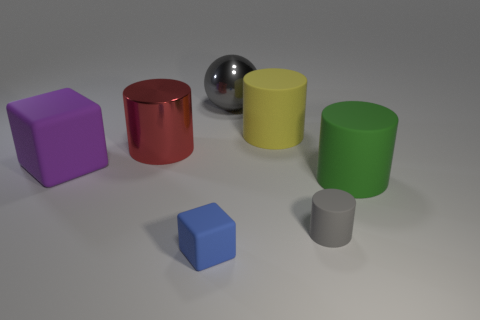How many gray metallic objects are the same size as the yellow object?
Your response must be concise. 1. There is a shiny object left of the metal sphere; is it the same size as the block that is in front of the large green rubber cylinder?
Provide a short and direct response. No. There is a gray object on the right side of the metal ball; what size is it?
Provide a succinct answer. Small. There is a rubber cylinder that is behind the large thing right of the big yellow rubber cylinder; what size is it?
Offer a terse response. Large. What is the material of the yellow thing that is the same size as the green cylinder?
Make the answer very short. Rubber. There is a small blue matte thing; are there any large purple blocks behind it?
Your answer should be very brief. Yes. Are there an equal number of gray objects to the right of the gray shiny thing and tiny red metal things?
Your answer should be very brief. No. What is the shape of the gray shiny thing that is the same size as the yellow cylinder?
Offer a terse response. Sphere. What material is the small gray cylinder?
Give a very brief answer. Rubber. The matte thing that is both on the left side of the yellow rubber object and behind the big green rubber cylinder is what color?
Give a very brief answer. Purple. 